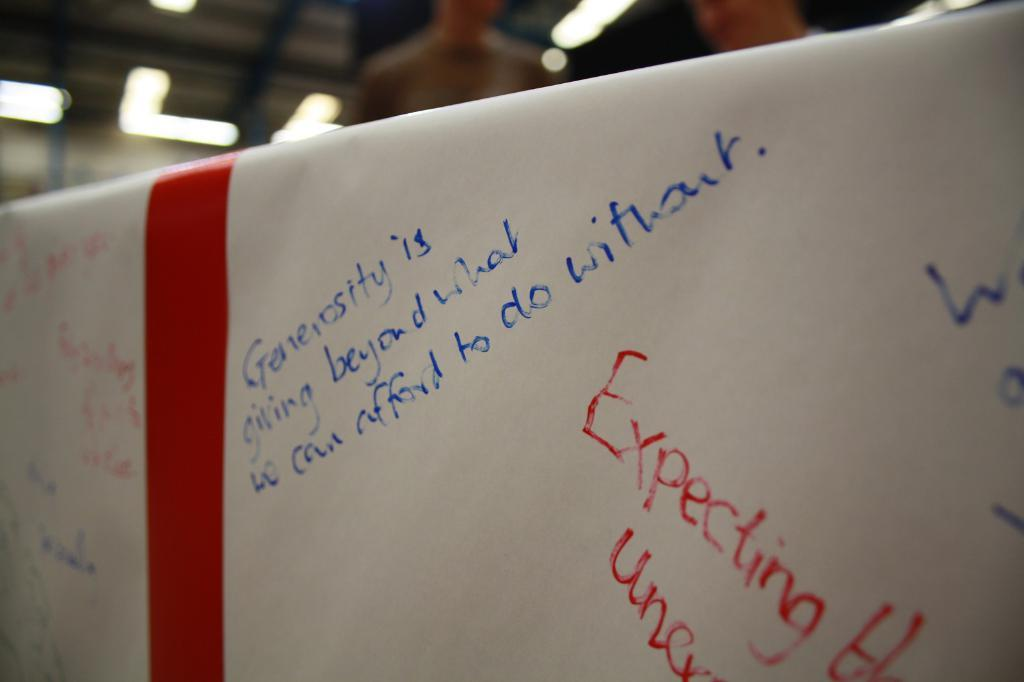<image>
Share a concise interpretation of the image provided. A handwritten note on a white board speaking about how generosity is defined in blue ink. with other phrases handwritten in various orientations. 